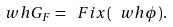Convert formula to latex. <formula><loc_0><loc_0><loc_500><loc_500>\ w h G _ { F } = \ F i x ( \ w h \phi ) .</formula> 